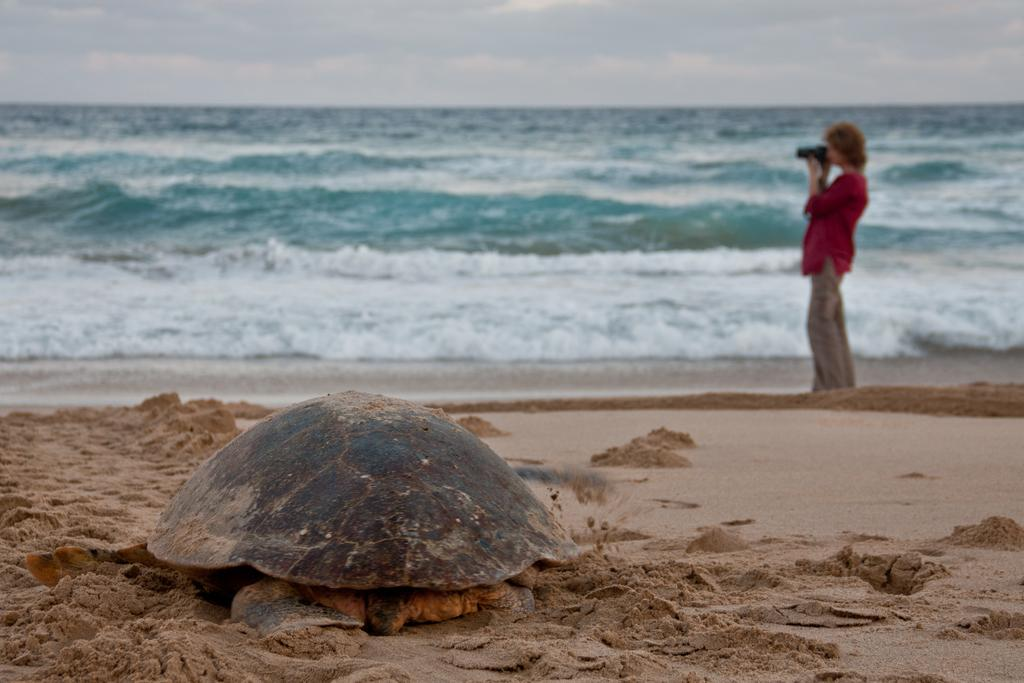What type of natural environment is depicted in the image? There is a sea in the image. What is the woman doing in the image? The woman is standing on the seashore and capturing a photo. Are there any animals visible in the image? Yes, there is a tortoise on the sand in the image. What type of polish is the woman applying to her nails in the image? There is no indication in the image that the woman is applying any polish to her nails. Can you tell me how many kitties are playing on the sand in the image? There are no kitties present in the image; it features a tortoise on the sand. 